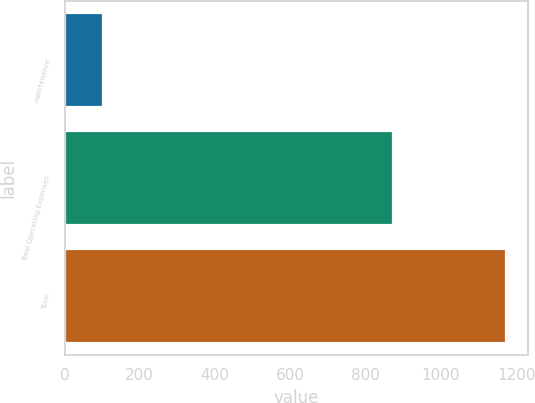Convert chart. <chart><loc_0><loc_0><loc_500><loc_500><bar_chart><fcel>maintenance<fcel>Total Operating Expenses<fcel>Total<nl><fcel>103<fcel>872<fcel>1172<nl></chart> 